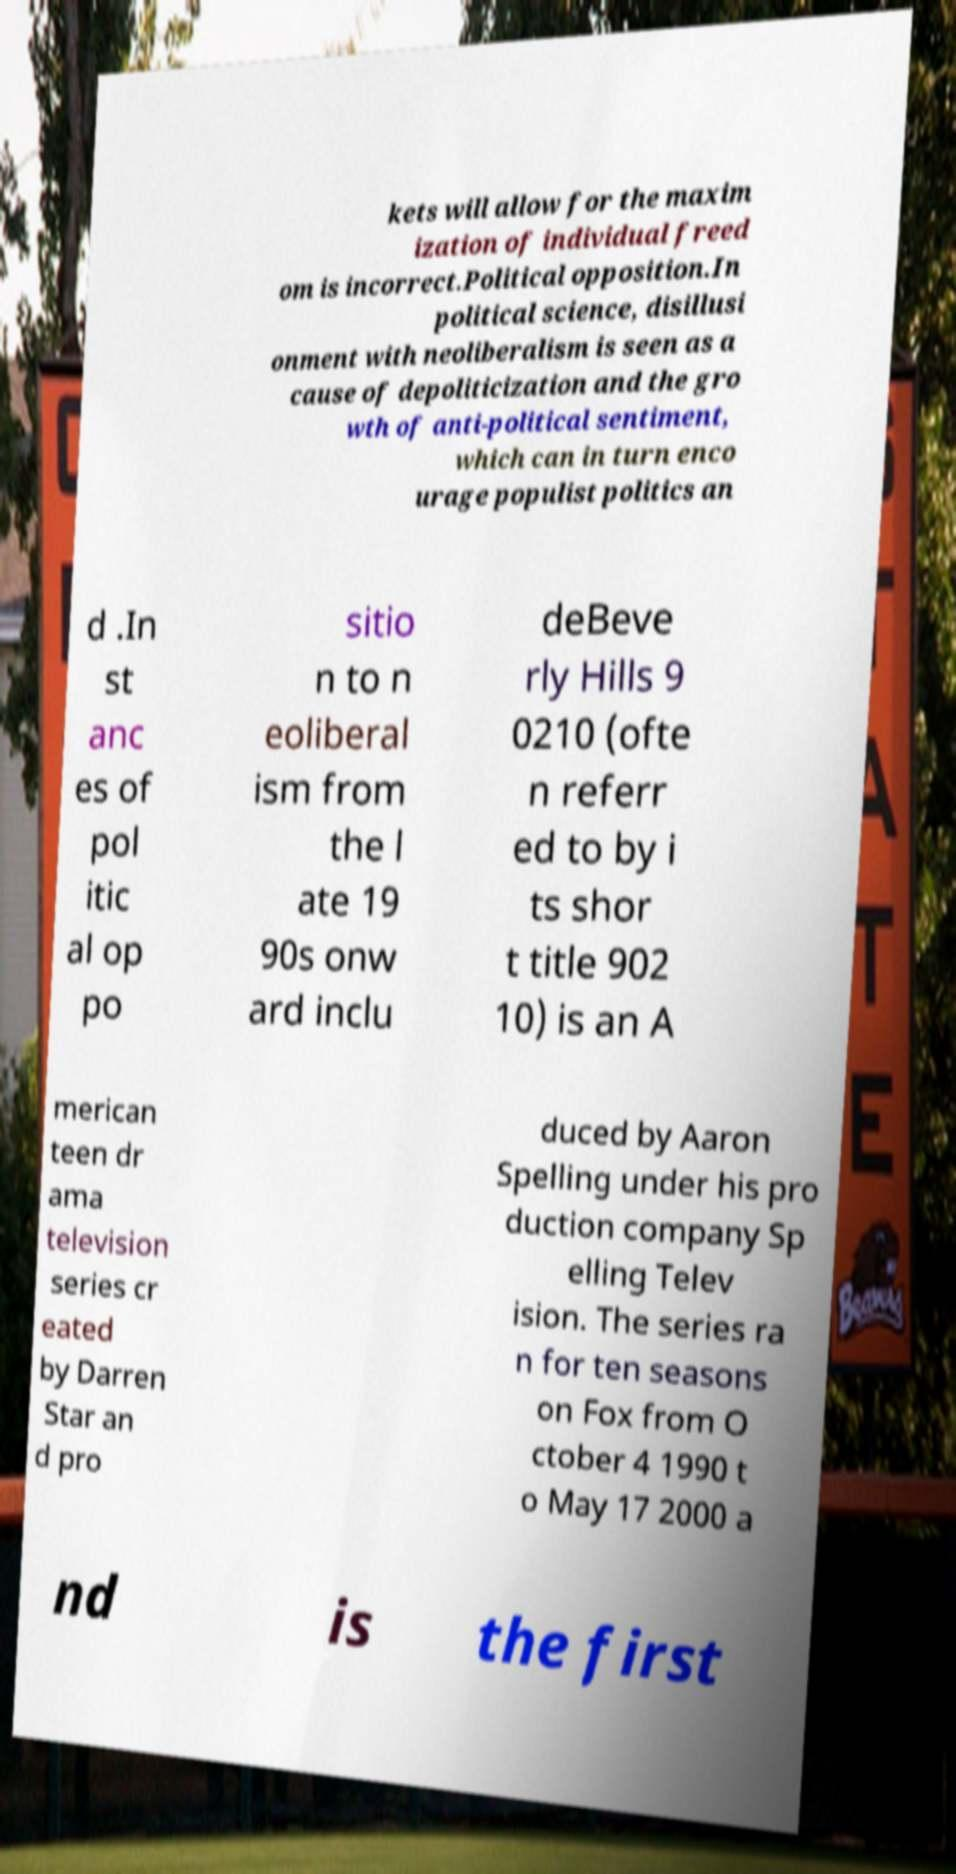There's text embedded in this image that I need extracted. Can you transcribe it verbatim? kets will allow for the maxim ization of individual freed om is incorrect.Political opposition.In political science, disillusi onment with neoliberalism is seen as a cause of depoliticization and the gro wth of anti-political sentiment, which can in turn enco urage populist politics an d .In st anc es of pol itic al op po sitio n to n eoliberal ism from the l ate 19 90s onw ard inclu deBeve rly Hills 9 0210 (ofte n referr ed to by i ts shor t title 902 10) is an A merican teen dr ama television series cr eated by Darren Star an d pro duced by Aaron Spelling under his pro duction company Sp elling Telev ision. The series ra n for ten seasons on Fox from O ctober 4 1990 t o May 17 2000 a nd is the first 